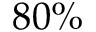<formula> <loc_0><loc_0><loc_500><loc_500>8 0 \%</formula> 